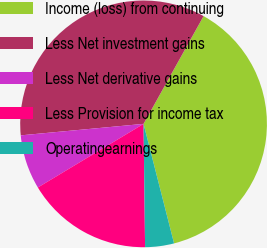Convert chart. <chart><loc_0><loc_0><loc_500><loc_500><pie_chart><fcel>Income (loss) from continuing<fcel>Less Net investment gains<fcel>Less Net derivative gains<fcel>Less Provision for income tax<fcel>Operatingearnings<nl><fcel>37.93%<fcel>34.57%<fcel>7.14%<fcel>16.57%<fcel>3.78%<nl></chart> 